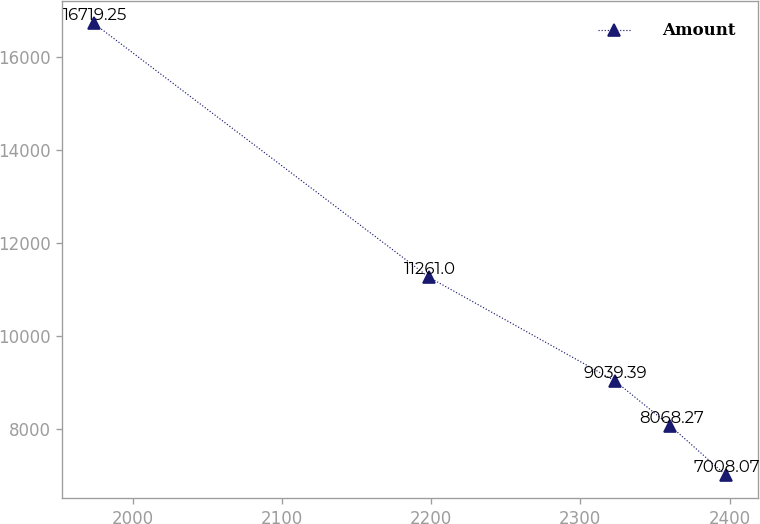Convert chart. <chart><loc_0><loc_0><loc_500><loc_500><line_chart><ecel><fcel>Amount<nl><fcel>1974.03<fcel>16719.2<nl><fcel>2198.78<fcel>11261<nl><fcel>2323.16<fcel>9039.39<nl><fcel>2360.44<fcel>8068.27<nl><fcel>2397.72<fcel>7008.07<nl></chart> 